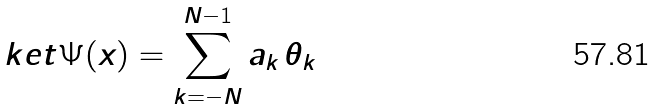<formula> <loc_0><loc_0><loc_500><loc_500>\ k e t { \Psi ( x ) } = \sum _ { k = - N } ^ { N - 1 } a _ { k } \, \theta _ { k }</formula> 